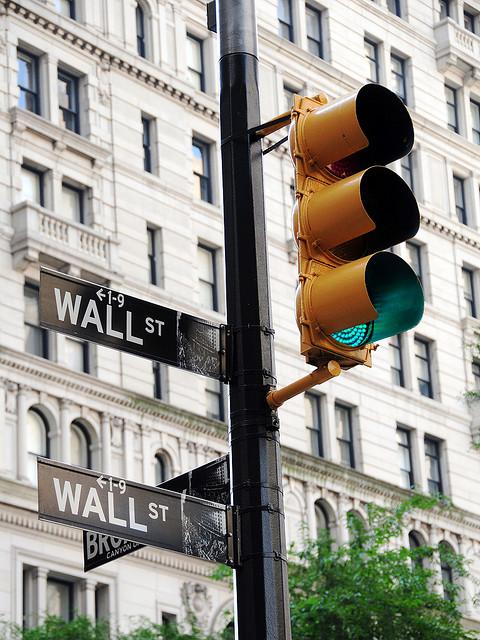What famous street is named in the photo?
Quick response, please. Wall. How many windows on the building in the background are open?
Be succinct. 0. Is the green traffic on?
Keep it brief. Yes. 